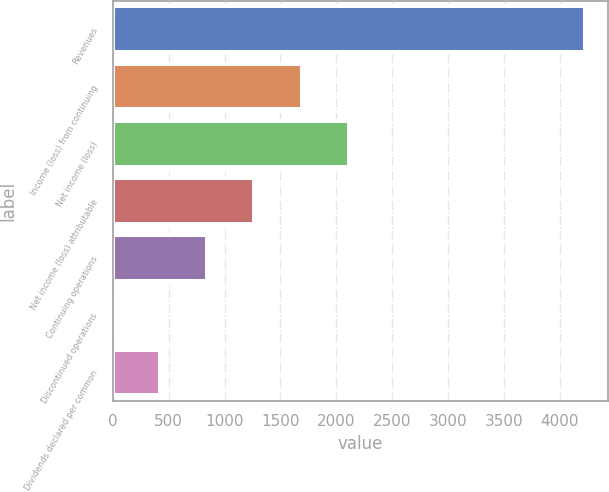<chart> <loc_0><loc_0><loc_500><loc_500><bar_chart><fcel>Revenues<fcel>Income (loss) from continuing<fcel>Net income (loss)<fcel>Net income (loss) attributable<fcel>Continuing operations<fcel>Discontinued operations<fcel>Dividends declared per common<nl><fcel>4221<fcel>1688.48<fcel>2110.57<fcel>1266.39<fcel>844.3<fcel>0.12<fcel>422.21<nl></chart> 